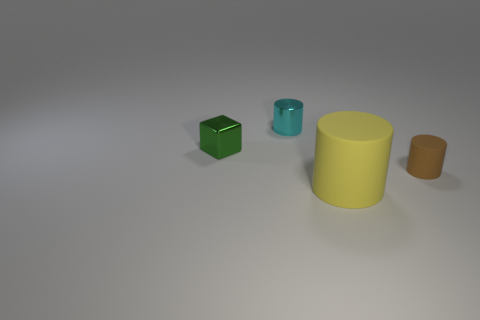Are there any big purple shiny things that have the same shape as the cyan shiny thing?
Provide a succinct answer. No. Does the tiny cylinder that is right of the small cyan object have the same material as the large thing that is to the left of the small brown object?
Make the answer very short. Yes. There is a thing left of the tiny cylinder that is left of the rubber cylinder that is right of the yellow rubber cylinder; what size is it?
Your answer should be compact. Small. There is a cyan cylinder that is the same size as the brown rubber cylinder; what is it made of?
Keep it short and to the point. Metal. Is there a green object that has the same size as the metallic cylinder?
Give a very brief answer. Yes. Is the tiny cyan metal object the same shape as the green object?
Offer a very short reply. No. Is there a large yellow matte object behind the tiny thing right of the cylinder that is behind the brown matte thing?
Offer a very short reply. No. How many other things are the same color as the tiny shiny cylinder?
Provide a short and direct response. 0. There is a thing that is behind the small green metal thing; is it the same size as the green block behind the large yellow rubber cylinder?
Your answer should be compact. Yes. Is the number of brown cylinders that are left of the green shiny block the same as the number of tiny metallic cubes that are behind the yellow thing?
Provide a short and direct response. No. 